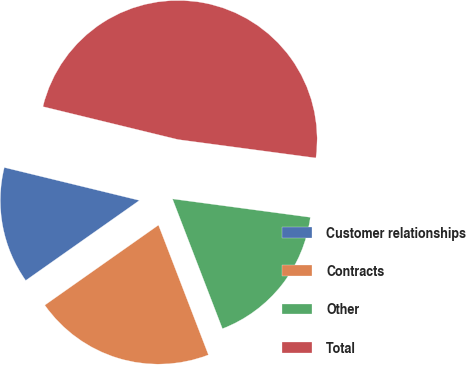Convert chart. <chart><loc_0><loc_0><loc_500><loc_500><pie_chart><fcel>Customer relationships<fcel>Contracts<fcel>Other<fcel>Total<nl><fcel>13.57%<fcel>21.08%<fcel>17.04%<fcel>48.31%<nl></chart> 